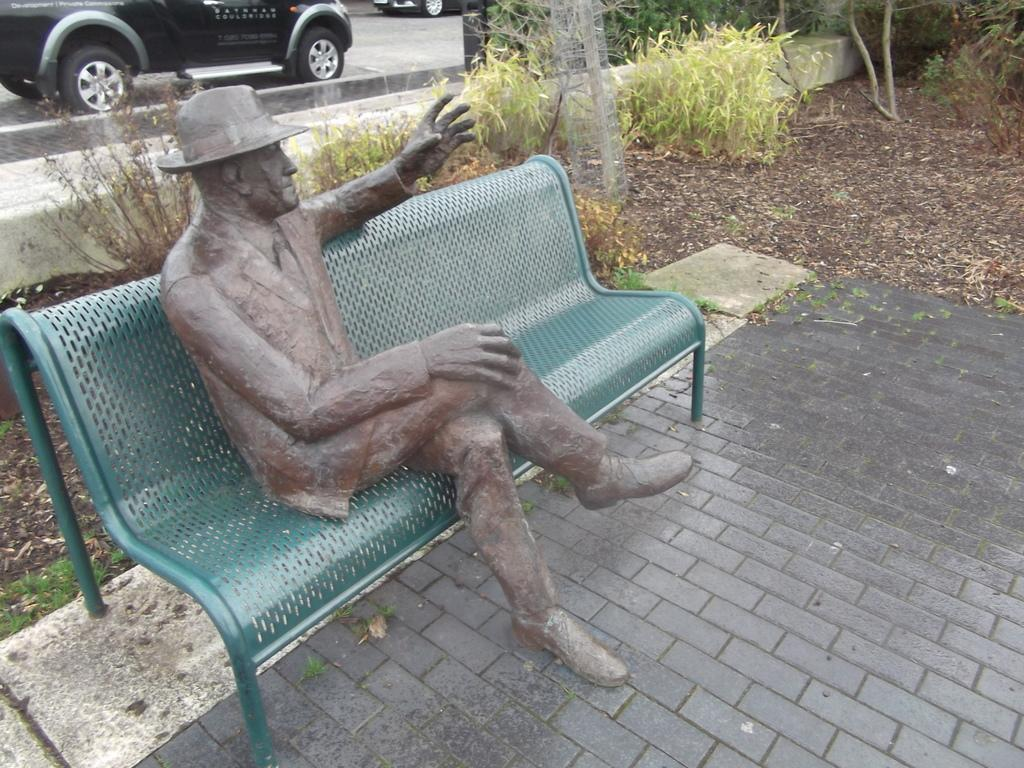What is the main subject in the image? There is a statue in the image. Where is the statue located? The statue is on a bench. What type of vegetation can be seen in the image? There are plants and grass visible in the image. What else can be seen on the ground in the image? There are vehicles on the ground in the image. Reasoning: Let's think step by following the guidelines to produce the conversation. We start by identifying the main subject, most prominent subject in the image, which is the statue. Then, we describe its location and other objects or elements in the image, such as the bench, plants, grass, and vehicles. Each question is designed to elicit a specific detail about the image that is known from the provided facts. Absurd Question/Answer: What type of blood is visible on the statue in the image? There is no blood visible on the statue or in the image. 